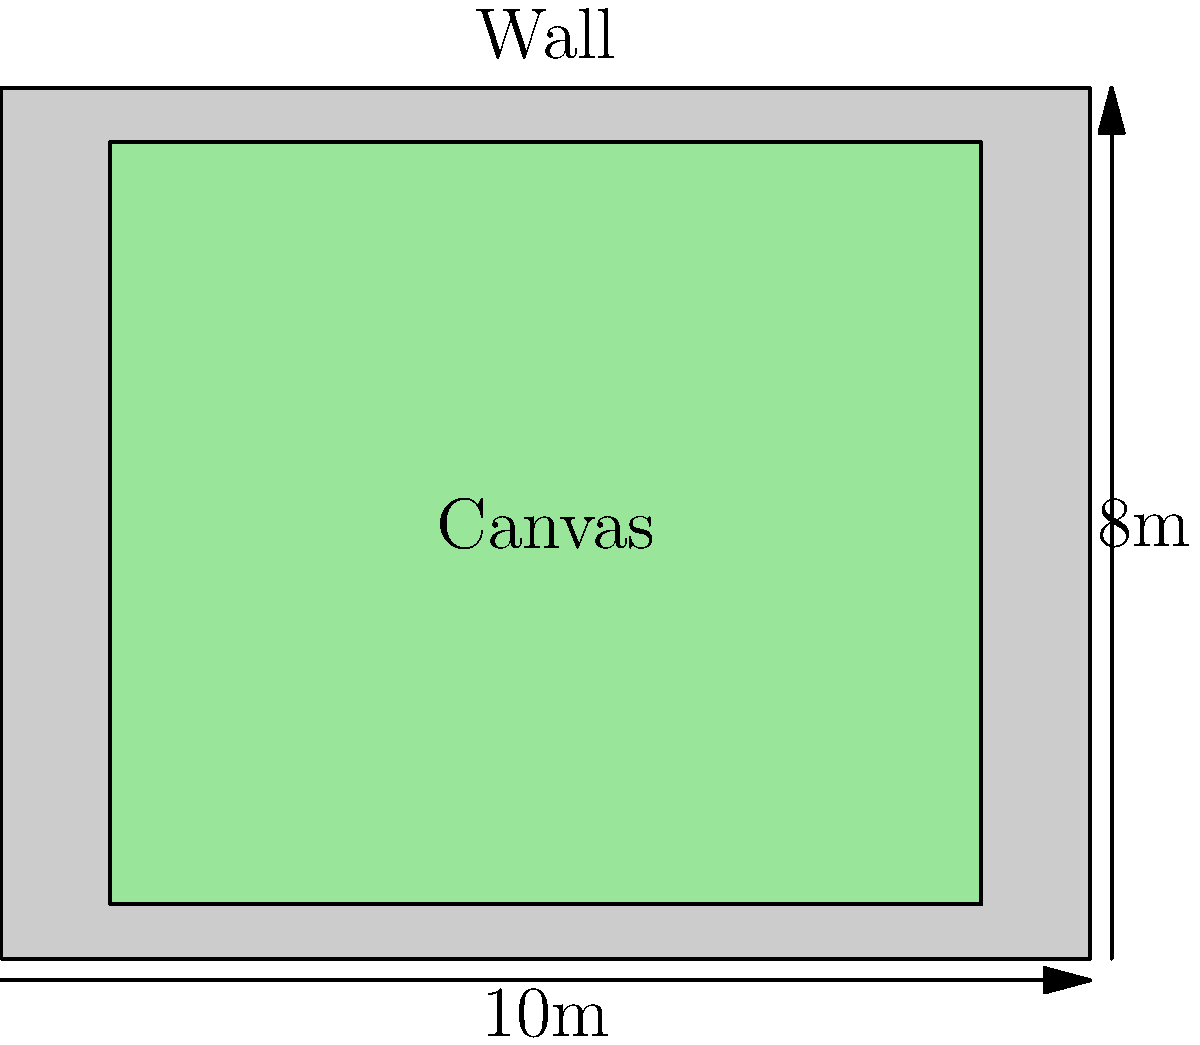You've been commissioned to create a mural on a wall measuring 10m wide by 8m high. To ensure proper framing and visibility, you decide to leave a 1m border on all sides of your canvas. What is the area of the largest rectangular canvas you can use for your mural? Let's approach this step-by-step:

1) First, we need to calculate the dimensions of the canvas:
   - Width of the canvas = Wall width - Left border - Right border
   - Width of the canvas = 10m - 1m - 1m = 8m
   - Height of the canvas = Wall height - Top border - Bottom border
   - Height of the canvas = 8m - 1m - 1m = 6m

2) Now that we have the dimensions of the canvas, we can calculate its area:
   - Area of a rectangle = Width × Height
   - Area of the canvas = 8m × 6m = 48m²

Therefore, the largest rectangular canvas you can use for your mural, leaving a 1m border on all sides, has an area of 48 square meters.
Answer: 48m² 